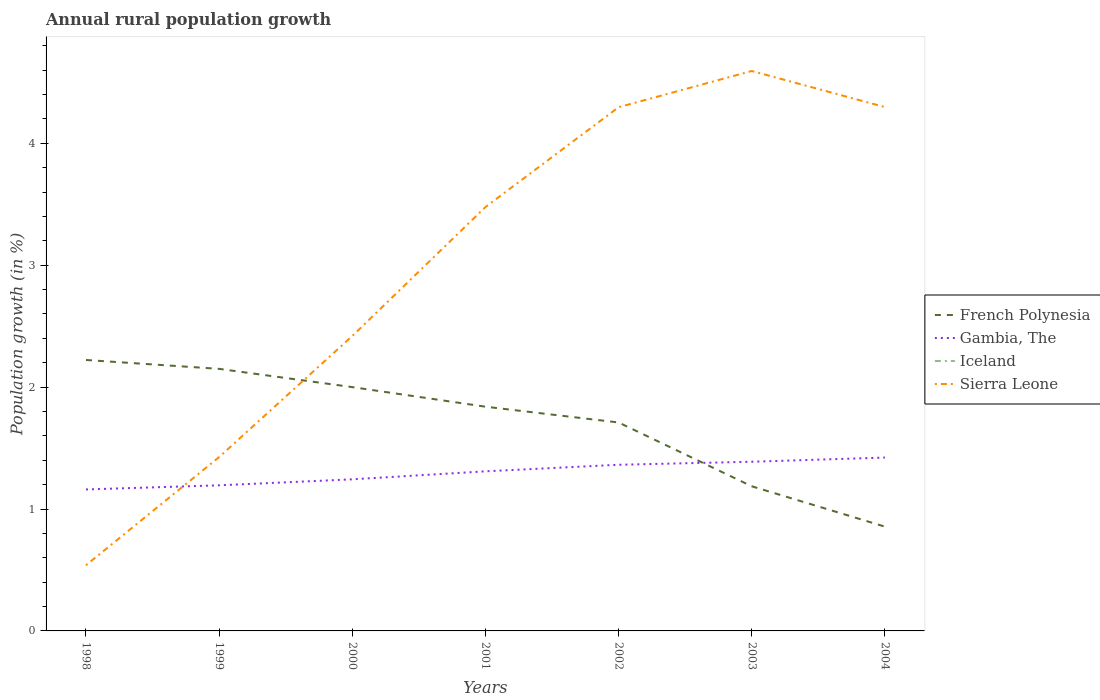What is the total percentage of rural population growth in French Polynesia in the graph?
Your answer should be compact. 1.04. What is the difference between the highest and the second highest percentage of rural population growth in Sierra Leone?
Make the answer very short. 4.05. What is the difference between the highest and the lowest percentage of rural population growth in French Polynesia?
Your answer should be very brief. 5. How many lines are there?
Offer a terse response. 3. Does the graph contain any zero values?
Make the answer very short. Yes. Does the graph contain grids?
Provide a succinct answer. No. Where does the legend appear in the graph?
Offer a very short reply. Center right. How many legend labels are there?
Offer a terse response. 4. How are the legend labels stacked?
Offer a very short reply. Vertical. What is the title of the graph?
Offer a very short reply. Annual rural population growth. Does "Ireland" appear as one of the legend labels in the graph?
Provide a succinct answer. No. What is the label or title of the Y-axis?
Your answer should be very brief. Population growth (in %). What is the Population growth (in %) in French Polynesia in 1998?
Provide a short and direct response. 2.22. What is the Population growth (in %) in Gambia, The in 1998?
Provide a short and direct response. 1.16. What is the Population growth (in %) in Iceland in 1998?
Your answer should be very brief. 0. What is the Population growth (in %) in Sierra Leone in 1998?
Ensure brevity in your answer.  0.54. What is the Population growth (in %) of French Polynesia in 1999?
Your answer should be very brief. 2.15. What is the Population growth (in %) in Gambia, The in 1999?
Make the answer very short. 1.19. What is the Population growth (in %) in Iceland in 1999?
Make the answer very short. 0. What is the Population growth (in %) in Sierra Leone in 1999?
Make the answer very short. 1.43. What is the Population growth (in %) in French Polynesia in 2000?
Offer a terse response. 2. What is the Population growth (in %) of Gambia, The in 2000?
Keep it short and to the point. 1.24. What is the Population growth (in %) of Iceland in 2000?
Offer a very short reply. 0. What is the Population growth (in %) of Sierra Leone in 2000?
Make the answer very short. 2.42. What is the Population growth (in %) of French Polynesia in 2001?
Provide a short and direct response. 1.84. What is the Population growth (in %) in Gambia, The in 2001?
Make the answer very short. 1.31. What is the Population growth (in %) in Iceland in 2001?
Offer a very short reply. 0. What is the Population growth (in %) in Sierra Leone in 2001?
Provide a succinct answer. 3.48. What is the Population growth (in %) in French Polynesia in 2002?
Your response must be concise. 1.71. What is the Population growth (in %) of Gambia, The in 2002?
Make the answer very short. 1.36. What is the Population growth (in %) of Iceland in 2002?
Your answer should be very brief. 0. What is the Population growth (in %) in Sierra Leone in 2002?
Offer a terse response. 4.3. What is the Population growth (in %) of French Polynesia in 2003?
Offer a terse response. 1.19. What is the Population growth (in %) in Gambia, The in 2003?
Offer a very short reply. 1.39. What is the Population growth (in %) in Iceland in 2003?
Make the answer very short. 0. What is the Population growth (in %) in Sierra Leone in 2003?
Your response must be concise. 4.59. What is the Population growth (in %) of French Polynesia in 2004?
Offer a terse response. 0.86. What is the Population growth (in %) of Gambia, The in 2004?
Offer a very short reply. 1.42. What is the Population growth (in %) of Sierra Leone in 2004?
Your response must be concise. 4.3. Across all years, what is the maximum Population growth (in %) of French Polynesia?
Keep it short and to the point. 2.22. Across all years, what is the maximum Population growth (in %) of Gambia, The?
Your answer should be compact. 1.42. Across all years, what is the maximum Population growth (in %) of Sierra Leone?
Offer a terse response. 4.59. Across all years, what is the minimum Population growth (in %) of French Polynesia?
Ensure brevity in your answer.  0.86. Across all years, what is the minimum Population growth (in %) of Gambia, The?
Your answer should be very brief. 1.16. Across all years, what is the minimum Population growth (in %) of Sierra Leone?
Give a very brief answer. 0.54. What is the total Population growth (in %) in French Polynesia in the graph?
Give a very brief answer. 11.96. What is the total Population growth (in %) of Gambia, The in the graph?
Your answer should be very brief. 9.08. What is the total Population growth (in %) of Sierra Leone in the graph?
Provide a short and direct response. 21.05. What is the difference between the Population growth (in %) in French Polynesia in 1998 and that in 1999?
Give a very brief answer. 0.07. What is the difference between the Population growth (in %) of Gambia, The in 1998 and that in 1999?
Your response must be concise. -0.03. What is the difference between the Population growth (in %) in Sierra Leone in 1998 and that in 1999?
Provide a succinct answer. -0.89. What is the difference between the Population growth (in %) of French Polynesia in 1998 and that in 2000?
Provide a short and direct response. 0.22. What is the difference between the Population growth (in %) in Gambia, The in 1998 and that in 2000?
Ensure brevity in your answer.  -0.08. What is the difference between the Population growth (in %) of Sierra Leone in 1998 and that in 2000?
Your answer should be compact. -1.88. What is the difference between the Population growth (in %) in French Polynesia in 1998 and that in 2001?
Keep it short and to the point. 0.38. What is the difference between the Population growth (in %) in Gambia, The in 1998 and that in 2001?
Offer a very short reply. -0.15. What is the difference between the Population growth (in %) in Sierra Leone in 1998 and that in 2001?
Your response must be concise. -2.94. What is the difference between the Population growth (in %) in French Polynesia in 1998 and that in 2002?
Keep it short and to the point. 0.51. What is the difference between the Population growth (in %) in Gambia, The in 1998 and that in 2002?
Provide a succinct answer. -0.2. What is the difference between the Population growth (in %) in Sierra Leone in 1998 and that in 2002?
Give a very brief answer. -3.76. What is the difference between the Population growth (in %) in French Polynesia in 1998 and that in 2003?
Provide a short and direct response. 1.04. What is the difference between the Population growth (in %) of Gambia, The in 1998 and that in 2003?
Provide a short and direct response. -0.23. What is the difference between the Population growth (in %) in Sierra Leone in 1998 and that in 2003?
Keep it short and to the point. -4.05. What is the difference between the Population growth (in %) in French Polynesia in 1998 and that in 2004?
Your answer should be very brief. 1.37. What is the difference between the Population growth (in %) in Gambia, The in 1998 and that in 2004?
Ensure brevity in your answer.  -0.26. What is the difference between the Population growth (in %) in Sierra Leone in 1998 and that in 2004?
Provide a short and direct response. -3.76. What is the difference between the Population growth (in %) in French Polynesia in 1999 and that in 2000?
Your response must be concise. 0.15. What is the difference between the Population growth (in %) in Gambia, The in 1999 and that in 2000?
Ensure brevity in your answer.  -0.05. What is the difference between the Population growth (in %) of Sierra Leone in 1999 and that in 2000?
Give a very brief answer. -0.99. What is the difference between the Population growth (in %) in French Polynesia in 1999 and that in 2001?
Offer a very short reply. 0.31. What is the difference between the Population growth (in %) of Gambia, The in 1999 and that in 2001?
Make the answer very short. -0.11. What is the difference between the Population growth (in %) of Sierra Leone in 1999 and that in 2001?
Your answer should be very brief. -2.05. What is the difference between the Population growth (in %) of French Polynesia in 1999 and that in 2002?
Provide a short and direct response. 0.44. What is the difference between the Population growth (in %) of Gambia, The in 1999 and that in 2002?
Your answer should be very brief. -0.17. What is the difference between the Population growth (in %) in Sierra Leone in 1999 and that in 2002?
Offer a very short reply. -2.87. What is the difference between the Population growth (in %) in French Polynesia in 1999 and that in 2003?
Keep it short and to the point. 0.96. What is the difference between the Population growth (in %) of Gambia, The in 1999 and that in 2003?
Provide a succinct answer. -0.19. What is the difference between the Population growth (in %) in Sierra Leone in 1999 and that in 2003?
Offer a very short reply. -3.17. What is the difference between the Population growth (in %) of French Polynesia in 1999 and that in 2004?
Your response must be concise. 1.29. What is the difference between the Population growth (in %) of Gambia, The in 1999 and that in 2004?
Your answer should be very brief. -0.23. What is the difference between the Population growth (in %) in Sierra Leone in 1999 and that in 2004?
Provide a short and direct response. -2.87. What is the difference between the Population growth (in %) in French Polynesia in 2000 and that in 2001?
Provide a succinct answer. 0.16. What is the difference between the Population growth (in %) in Gambia, The in 2000 and that in 2001?
Provide a succinct answer. -0.07. What is the difference between the Population growth (in %) in Sierra Leone in 2000 and that in 2001?
Your response must be concise. -1.06. What is the difference between the Population growth (in %) of French Polynesia in 2000 and that in 2002?
Your answer should be very brief. 0.29. What is the difference between the Population growth (in %) of Gambia, The in 2000 and that in 2002?
Offer a terse response. -0.12. What is the difference between the Population growth (in %) in Sierra Leone in 2000 and that in 2002?
Provide a succinct answer. -1.88. What is the difference between the Population growth (in %) of French Polynesia in 2000 and that in 2003?
Offer a terse response. 0.81. What is the difference between the Population growth (in %) of Gambia, The in 2000 and that in 2003?
Your answer should be very brief. -0.14. What is the difference between the Population growth (in %) in Sierra Leone in 2000 and that in 2003?
Make the answer very short. -2.17. What is the difference between the Population growth (in %) in French Polynesia in 2000 and that in 2004?
Your answer should be very brief. 1.14. What is the difference between the Population growth (in %) in Gambia, The in 2000 and that in 2004?
Ensure brevity in your answer.  -0.18. What is the difference between the Population growth (in %) of Sierra Leone in 2000 and that in 2004?
Ensure brevity in your answer.  -1.88. What is the difference between the Population growth (in %) of French Polynesia in 2001 and that in 2002?
Make the answer very short. 0.13. What is the difference between the Population growth (in %) of Gambia, The in 2001 and that in 2002?
Offer a terse response. -0.05. What is the difference between the Population growth (in %) in Sierra Leone in 2001 and that in 2002?
Keep it short and to the point. -0.82. What is the difference between the Population growth (in %) of French Polynesia in 2001 and that in 2003?
Provide a succinct answer. 0.65. What is the difference between the Population growth (in %) in Gambia, The in 2001 and that in 2003?
Your answer should be compact. -0.08. What is the difference between the Population growth (in %) of Sierra Leone in 2001 and that in 2003?
Your answer should be very brief. -1.12. What is the difference between the Population growth (in %) of French Polynesia in 2001 and that in 2004?
Ensure brevity in your answer.  0.98. What is the difference between the Population growth (in %) of Gambia, The in 2001 and that in 2004?
Offer a terse response. -0.11. What is the difference between the Population growth (in %) in Sierra Leone in 2001 and that in 2004?
Offer a very short reply. -0.82. What is the difference between the Population growth (in %) in French Polynesia in 2002 and that in 2003?
Your response must be concise. 0.52. What is the difference between the Population growth (in %) of Gambia, The in 2002 and that in 2003?
Make the answer very short. -0.02. What is the difference between the Population growth (in %) in Sierra Leone in 2002 and that in 2003?
Make the answer very short. -0.3. What is the difference between the Population growth (in %) in French Polynesia in 2002 and that in 2004?
Your answer should be very brief. 0.85. What is the difference between the Population growth (in %) in Gambia, The in 2002 and that in 2004?
Your response must be concise. -0.06. What is the difference between the Population growth (in %) in Sierra Leone in 2002 and that in 2004?
Your answer should be compact. -0. What is the difference between the Population growth (in %) in French Polynesia in 2003 and that in 2004?
Make the answer very short. 0.33. What is the difference between the Population growth (in %) of Gambia, The in 2003 and that in 2004?
Your answer should be very brief. -0.03. What is the difference between the Population growth (in %) of Sierra Leone in 2003 and that in 2004?
Offer a terse response. 0.3. What is the difference between the Population growth (in %) in French Polynesia in 1998 and the Population growth (in %) in Gambia, The in 1999?
Your answer should be compact. 1.03. What is the difference between the Population growth (in %) in French Polynesia in 1998 and the Population growth (in %) in Sierra Leone in 1999?
Make the answer very short. 0.8. What is the difference between the Population growth (in %) of Gambia, The in 1998 and the Population growth (in %) of Sierra Leone in 1999?
Keep it short and to the point. -0.27. What is the difference between the Population growth (in %) in French Polynesia in 1998 and the Population growth (in %) in Gambia, The in 2000?
Provide a short and direct response. 0.98. What is the difference between the Population growth (in %) of French Polynesia in 1998 and the Population growth (in %) of Sierra Leone in 2000?
Provide a succinct answer. -0.2. What is the difference between the Population growth (in %) in Gambia, The in 1998 and the Population growth (in %) in Sierra Leone in 2000?
Offer a very short reply. -1.26. What is the difference between the Population growth (in %) in French Polynesia in 1998 and the Population growth (in %) in Gambia, The in 2001?
Offer a terse response. 0.91. What is the difference between the Population growth (in %) in French Polynesia in 1998 and the Population growth (in %) in Sierra Leone in 2001?
Offer a terse response. -1.25. What is the difference between the Population growth (in %) of Gambia, The in 1998 and the Population growth (in %) of Sierra Leone in 2001?
Your answer should be very brief. -2.32. What is the difference between the Population growth (in %) in French Polynesia in 1998 and the Population growth (in %) in Gambia, The in 2002?
Offer a very short reply. 0.86. What is the difference between the Population growth (in %) in French Polynesia in 1998 and the Population growth (in %) in Sierra Leone in 2002?
Offer a very short reply. -2.07. What is the difference between the Population growth (in %) in Gambia, The in 1998 and the Population growth (in %) in Sierra Leone in 2002?
Make the answer very short. -3.14. What is the difference between the Population growth (in %) in French Polynesia in 1998 and the Population growth (in %) in Gambia, The in 2003?
Provide a succinct answer. 0.83. What is the difference between the Population growth (in %) of French Polynesia in 1998 and the Population growth (in %) of Sierra Leone in 2003?
Give a very brief answer. -2.37. What is the difference between the Population growth (in %) of Gambia, The in 1998 and the Population growth (in %) of Sierra Leone in 2003?
Your response must be concise. -3.43. What is the difference between the Population growth (in %) of French Polynesia in 1998 and the Population growth (in %) of Gambia, The in 2004?
Your answer should be very brief. 0.8. What is the difference between the Population growth (in %) in French Polynesia in 1998 and the Population growth (in %) in Sierra Leone in 2004?
Ensure brevity in your answer.  -2.07. What is the difference between the Population growth (in %) in Gambia, The in 1998 and the Population growth (in %) in Sierra Leone in 2004?
Your answer should be compact. -3.14. What is the difference between the Population growth (in %) of French Polynesia in 1999 and the Population growth (in %) of Gambia, The in 2000?
Keep it short and to the point. 0.91. What is the difference between the Population growth (in %) of French Polynesia in 1999 and the Population growth (in %) of Sierra Leone in 2000?
Offer a terse response. -0.27. What is the difference between the Population growth (in %) in Gambia, The in 1999 and the Population growth (in %) in Sierra Leone in 2000?
Offer a very short reply. -1.22. What is the difference between the Population growth (in %) in French Polynesia in 1999 and the Population growth (in %) in Gambia, The in 2001?
Provide a succinct answer. 0.84. What is the difference between the Population growth (in %) of French Polynesia in 1999 and the Population growth (in %) of Sierra Leone in 2001?
Make the answer very short. -1.33. What is the difference between the Population growth (in %) of Gambia, The in 1999 and the Population growth (in %) of Sierra Leone in 2001?
Your response must be concise. -2.28. What is the difference between the Population growth (in %) of French Polynesia in 1999 and the Population growth (in %) of Gambia, The in 2002?
Provide a succinct answer. 0.79. What is the difference between the Population growth (in %) of French Polynesia in 1999 and the Population growth (in %) of Sierra Leone in 2002?
Provide a succinct answer. -2.15. What is the difference between the Population growth (in %) in Gambia, The in 1999 and the Population growth (in %) in Sierra Leone in 2002?
Make the answer very short. -3.1. What is the difference between the Population growth (in %) in French Polynesia in 1999 and the Population growth (in %) in Gambia, The in 2003?
Your response must be concise. 0.76. What is the difference between the Population growth (in %) in French Polynesia in 1999 and the Population growth (in %) in Sierra Leone in 2003?
Provide a short and direct response. -2.44. What is the difference between the Population growth (in %) in Gambia, The in 1999 and the Population growth (in %) in Sierra Leone in 2003?
Give a very brief answer. -3.4. What is the difference between the Population growth (in %) of French Polynesia in 1999 and the Population growth (in %) of Gambia, The in 2004?
Provide a succinct answer. 0.73. What is the difference between the Population growth (in %) of French Polynesia in 1999 and the Population growth (in %) of Sierra Leone in 2004?
Give a very brief answer. -2.15. What is the difference between the Population growth (in %) of Gambia, The in 1999 and the Population growth (in %) of Sierra Leone in 2004?
Offer a very short reply. -3.1. What is the difference between the Population growth (in %) of French Polynesia in 2000 and the Population growth (in %) of Gambia, The in 2001?
Keep it short and to the point. 0.69. What is the difference between the Population growth (in %) of French Polynesia in 2000 and the Population growth (in %) of Sierra Leone in 2001?
Your response must be concise. -1.48. What is the difference between the Population growth (in %) of Gambia, The in 2000 and the Population growth (in %) of Sierra Leone in 2001?
Provide a succinct answer. -2.23. What is the difference between the Population growth (in %) of French Polynesia in 2000 and the Population growth (in %) of Gambia, The in 2002?
Keep it short and to the point. 0.64. What is the difference between the Population growth (in %) of French Polynesia in 2000 and the Population growth (in %) of Sierra Leone in 2002?
Your response must be concise. -2.3. What is the difference between the Population growth (in %) of Gambia, The in 2000 and the Population growth (in %) of Sierra Leone in 2002?
Provide a succinct answer. -3.05. What is the difference between the Population growth (in %) in French Polynesia in 2000 and the Population growth (in %) in Gambia, The in 2003?
Give a very brief answer. 0.61. What is the difference between the Population growth (in %) in French Polynesia in 2000 and the Population growth (in %) in Sierra Leone in 2003?
Ensure brevity in your answer.  -2.59. What is the difference between the Population growth (in %) in Gambia, The in 2000 and the Population growth (in %) in Sierra Leone in 2003?
Your answer should be very brief. -3.35. What is the difference between the Population growth (in %) in French Polynesia in 2000 and the Population growth (in %) in Gambia, The in 2004?
Your answer should be very brief. 0.58. What is the difference between the Population growth (in %) of French Polynesia in 2000 and the Population growth (in %) of Sierra Leone in 2004?
Provide a succinct answer. -2.3. What is the difference between the Population growth (in %) in Gambia, The in 2000 and the Population growth (in %) in Sierra Leone in 2004?
Ensure brevity in your answer.  -3.05. What is the difference between the Population growth (in %) of French Polynesia in 2001 and the Population growth (in %) of Gambia, The in 2002?
Your answer should be very brief. 0.48. What is the difference between the Population growth (in %) in French Polynesia in 2001 and the Population growth (in %) in Sierra Leone in 2002?
Keep it short and to the point. -2.46. What is the difference between the Population growth (in %) in Gambia, The in 2001 and the Population growth (in %) in Sierra Leone in 2002?
Your response must be concise. -2.99. What is the difference between the Population growth (in %) in French Polynesia in 2001 and the Population growth (in %) in Gambia, The in 2003?
Keep it short and to the point. 0.45. What is the difference between the Population growth (in %) in French Polynesia in 2001 and the Population growth (in %) in Sierra Leone in 2003?
Your answer should be very brief. -2.75. What is the difference between the Population growth (in %) of Gambia, The in 2001 and the Population growth (in %) of Sierra Leone in 2003?
Make the answer very short. -3.28. What is the difference between the Population growth (in %) of French Polynesia in 2001 and the Population growth (in %) of Gambia, The in 2004?
Offer a terse response. 0.42. What is the difference between the Population growth (in %) in French Polynesia in 2001 and the Population growth (in %) in Sierra Leone in 2004?
Your answer should be very brief. -2.46. What is the difference between the Population growth (in %) in Gambia, The in 2001 and the Population growth (in %) in Sierra Leone in 2004?
Make the answer very short. -2.99. What is the difference between the Population growth (in %) of French Polynesia in 2002 and the Population growth (in %) of Gambia, The in 2003?
Keep it short and to the point. 0.32. What is the difference between the Population growth (in %) of French Polynesia in 2002 and the Population growth (in %) of Sierra Leone in 2003?
Give a very brief answer. -2.88. What is the difference between the Population growth (in %) in Gambia, The in 2002 and the Population growth (in %) in Sierra Leone in 2003?
Your answer should be very brief. -3.23. What is the difference between the Population growth (in %) of French Polynesia in 2002 and the Population growth (in %) of Gambia, The in 2004?
Give a very brief answer. 0.29. What is the difference between the Population growth (in %) of French Polynesia in 2002 and the Population growth (in %) of Sierra Leone in 2004?
Give a very brief answer. -2.59. What is the difference between the Population growth (in %) of Gambia, The in 2002 and the Population growth (in %) of Sierra Leone in 2004?
Give a very brief answer. -2.93. What is the difference between the Population growth (in %) in French Polynesia in 2003 and the Population growth (in %) in Gambia, The in 2004?
Ensure brevity in your answer.  -0.24. What is the difference between the Population growth (in %) of French Polynesia in 2003 and the Population growth (in %) of Sierra Leone in 2004?
Provide a short and direct response. -3.11. What is the difference between the Population growth (in %) in Gambia, The in 2003 and the Population growth (in %) in Sierra Leone in 2004?
Offer a terse response. -2.91. What is the average Population growth (in %) of French Polynesia per year?
Offer a very short reply. 1.71. What is the average Population growth (in %) of Gambia, The per year?
Your answer should be very brief. 1.3. What is the average Population growth (in %) of Iceland per year?
Ensure brevity in your answer.  0. What is the average Population growth (in %) in Sierra Leone per year?
Make the answer very short. 3.01. In the year 1998, what is the difference between the Population growth (in %) in French Polynesia and Population growth (in %) in Gambia, The?
Offer a terse response. 1.06. In the year 1998, what is the difference between the Population growth (in %) in French Polynesia and Population growth (in %) in Sierra Leone?
Your answer should be very brief. 1.68. In the year 1998, what is the difference between the Population growth (in %) of Gambia, The and Population growth (in %) of Sierra Leone?
Your response must be concise. 0.62. In the year 1999, what is the difference between the Population growth (in %) in French Polynesia and Population growth (in %) in Gambia, The?
Your answer should be compact. 0.96. In the year 1999, what is the difference between the Population growth (in %) of French Polynesia and Population growth (in %) of Sierra Leone?
Ensure brevity in your answer.  0.72. In the year 1999, what is the difference between the Population growth (in %) in Gambia, The and Population growth (in %) in Sierra Leone?
Your response must be concise. -0.23. In the year 2000, what is the difference between the Population growth (in %) of French Polynesia and Population growth (in %) of Gambia, The?
Offer a terse response. 0.76. In the year 2000, what is the difference between the Population growth (in %) of French Polynesia and Population growth (in %) of Sierra Leone?
Offer a very short reply. -0.42. In the year 2000, what is the difference between the Population growth (in %) in Gambia, The and Population growth (in %) in Sierra Leone?
Offer a very short reply. -1.18. In the year 2001, what is the difference between the Population growth (in %) in French Polynesia and Population growth (in %) in Gambia, The?
Make the answer very short. 0.53. In the year 2001, what is the difference between the Population growth (in %) in French Polynesia and Population growth (in %) in Sierra Leone?
Your response must be concise. -1.64. In the year 2001, what is the difference between the Population growth (in %) of Gambia, The and Population growth (in %) of Sierra Leone?
Ensure brevity in your answer.  -2.17. In the year 2002, what is the difference between the Population growth (in %) of French Polynesia and Population growth (in %) of Gambia, The?
Provide a succinct answer. 0.35. In the year 2002, what is the difference between the Population growth (in %) of French Polynesia and Population growth (in %) of Sierra Leone?
Offer a terse response. -2.59. In the year 2002, what is the difference between the Population growth (in %) of Gambia, The and Population growth (in %) of Sierra Leone?
Your answer should be compact. -2.93. In the year 2003, what is the difference between the Population growth (in %) of French Polynesia and Population growth (in %) of Gambia, The?
Keep it short and to the point. -0.2. In the year 2003, what is the difference between the Population growth (in %) of French Polynesia and Population growth (in %) of Sierra Leone?
Your answer should be very brief. -3.41. In the year 2003, what is the difference between the Population growth (in %) in Gambia, The and Population growth (in %) in Sierra Leone?
Keep it short and to the point. -3.21. In the year 2004, what is the difference between the Population growth (in %) in French Polynesia and Population growth (in %) in Gambia, The?
Your answer should be very brief. -0.57. In the year 2004, what is the difference between the Population growth (in %) of French Polynesia and Population growth (in %) of Sierra Leone?
Provide a succinct answer. -3.44. In the year 2004, what is the difference between the Population growth (in %) of Gambia, The and Population growth (in %) of Sierra Leone?
Ensure brevity in your answer.  -2.88. What is the ratio of the Population growth (in %) in French Polynesia in 1998 to that in 1999?
Keep it short and to the point. 1.03. What is the ratio of the Population growth (in %) of Gambia, The in 1998 to that in 1999?
Your answer should be very brief. 0.97. What is the ratio of the Population growth (in %) in Sierra Leone in 1998 to that in 1999?
Make the answer very short. 0.38. What is the ratio of the Population growth (in %) of French Polynesia in 1998 to that in 2000?
Give a very brief answer. 1.11. What is the ratio of the Population growth (in %) in Gambia, The in 1998 to that in 2000?
Offer a very short reply. 0.93. What is the ratio of the Population growth (in %) of Sierra Leone in 1998 to that in 2000?
Ensure brevity in your answer.  0.22. What is the ratio of the Population growth (in %) of French Polynesia in 1998 to that in 2001?
Keep it short and to the point. 1.21. What is the ratio of the Population growth (in %) of Gambia, The in 1998 to that in 2001?
Your response must be concise. 0.89. What is the ratio of the Population growth (in %) of Sierra Leone in 1998 to that in 2001?
Give a very brief answer. 0.15. What is the ratio of the Population growth (in %) of French Polynesia in 1998 to that in 2002?
Offer a very short reply. 1.3. What is the ratio of the Population growth (in %) in Gambia, The in 1998 to that in 2002?
Give a very brief answer. 0.85. What is the ratio of the Population growth (in %) in Sierra Leone in 1998 to that in 2002?
Make the answer very short. 0.13. What is the ratio of the Population growth (in %) in French Polynesia in 1998 to that in 2003?
Keep it short and to the point. 1.87. What is the ratio of the Population growth (in %) of Gambia, The in 1998 to that in 2003?
Ensure brevity in your answer.  0.84. What is the ratio of the Population growth (in %) of Sierra Leone in 1998 to that in 2003?
Your response must be concise. 0.12. What is the ratio of the Population growth (in %) of French Polynesia in 1998 to that in 2004?
Offer a very short reply. 2.6. What is the ratio of the Population growth (in %) of Gambia, The in 1998 to that in 2004?
Provide a short and direct response. 0.82. What is the ratio of the Population growth (in %) in Sierra Leone in 1998 to that in 2004?
Offer a terse response. 0.13. What is the ratio of the Population growth (in %) of French Polynesia in 1999 to that in 2000?
Make the answer very short. 1.07. What is the ratio of the Population growth (in %) of Gambia, The in 1999 to that in 2000?
Offer a terse response. 0.96. What is the ratio of the Population growth (in %) of Sierra Leone in 1999 to that in 2000?
Offer a terse response. 0.59. What is the ratio of the Population growth (in %) of French Polynesia in 1999 to that in 2001?
Your answer should be compact. 1.17. What is the ratio of the Population growth (in %) in Gambia, The in 1999 to that in 2001?
Offer a very short reply. 0.91. What is the ratio of the Population growth (in %) in Sierra Leone in 1999 to that in 2001?
Provide a succinct answer. 0.41. What is the ratio of the Population growth (in %) in French Polynesia in 1999 to that in 2002?
Offer a very short reply. 1.26. What is the ratio of the Population growth (in %) in Gambia, The in 1999 to that in 2002?
Offer a terse response. 0.88. What is the ratio of the Population growth (in %) of Sierra Leone in 1999 to that in 2002?
Ensure brevity in your answer.  0.33. What is the ratio of the Population growth (in %) in French Polynesia in 1999 to that in 2003?
Offer a terse response. 1.81. What is the ratio of the Population growth (in %) of Gambia, The in 1999 to that in 2003?
Offer a very short reply. 0.86. What is the ratio of the Population growth (in %) in Sierra Leone in 1999 to that in 2003?
Give a very brief answer. 0.31. What is the ratio of the Population growth (in %) of French Polynesia in 1999 to that in 2004?
Offer a terse response. 2.51. What is the ratio of the Population growth (in %) in Gambia, The in 1999 to that in 2004?
Your response must be concise. 0.84. What is the ratio of the Population growth (in %) in Sierra Leone in 1999 to that in 2004?
Offer a very short reply. 0.33. What is the ratio of the Population growth (in %) of French Polynesia in 2000 to that in 2001?
Your response must be concise. 1.09. What is the ratio of the Population growth (in %) of Gambia, The in 2000 to that in 2001?
Provide a short and direct response. 0.95. What is the ratio of the Population growth (in %) of Sierra Leone in 2000 to that in 2001?
Keep it short and to the point. 0.7. What is the ratio of the Population growth (in %) of French Polynesia in 2000 to that in 2002?
Your answer should be very brief. 1.17. What is the ratio of the Population growth (in %) of Gambia, The in 2000 to that in 2002?
Provide a succinct answer. 0.91. What is the ratio of the Population growth (in %) of Sierra Leone in 2000 to that in 2002?
Provide a short and direct response. 0.56. What is the ratio of the Population growth (in %) in French Polynesia in 2000 to that in 2003?
Your answer should be very brief. 1.69. What is the ratio of the Population growth (in %) of Gambia, The in 2000 to that in 2003?
Make the answer very short. 0.9. What is the ratio of the Population growth (in %) in Sierra Leone in 2000 to that in 2003?
Offer a very short reply. 0.53. What is the ratio of the Population growth (in %) of French Polynesia in 2000 to that in 2004?
Provide a succinct answer. 2.34. What is the ratio of the Population growth (in %) in Gambia, The in 2000 to that in 2004?
Make the answer very short. 0.87. What is the ratio of the Population growth (in %) of Sierra Leone in 2000 to that in 2004?
Your answer should be compact. 0.56. What is the ratio of the Population growth (in %) of French Polynesia in 2001 to that in 2002?
Your response must be concise. 1.08. What is the ratio of the Population growth (in %) of Gambia, The in 2001 to that in 2002?
Provide a succinct answer. 0.96. What is the ratio of the Population growth (in %) in Sierra Leone in 2001 to that in 2002?
Keep it short and to the point. 0.81. What is the ratio of the Population growth (in %) in French Polynesia in 2001 to that in 2003?
Offer a terse response. 1.55. What is the ratio of the Population growth (in %) of Gambia, The in 2001 to that in 2003?
Offer a very short reply. 0.94. What is the ratio of the Population growth (in %) of Sierra Leone in 2001 to that in 2003?
Keep it short and to the point. 0.76. What is the ratio of the Population growth (in %) of French Polynesia in 2001 to that in 2004?
Offer a terse response. 2.15. What is the ratio of the Population growth (in %) of Gambia, The in 2001 to that in 2004?
Offer a terse response. 0.92. What is the ratio of the Population growth (in %) of Sierra Leone in 2001 to that in 2004?
Provide a short and direct response. 0.81. What is the ratio of the Population growth (in %) of French Polynesia in 2002 to that in 2003?
Your answer should be compact. 1.44. What is the ratio of the Population growth (in %) of Gambia, The in 2002 to that in 2003?
Your answer should be very brief. 0.98. What is the ratio of the Population growth (in %) in Sierra Leone in 2002 to that in 2003?
Make the answer very short. 0.94. What is the ratio of the Population growth (in %) in French Polynesia in 2002 to that in 2004?
Offer a very short reply. 2. What is the ratio of the Population growth (in %) of Gambia, The in 2002 to that in 2004?
Offer a very short reply. 0.96. What is the ratio of the Population growth (in %) of French Polynesia in 2003 to that in 2004?
Give a very brief answer. 1.39. What is the ratio of the Population growth (in %) of Gambia, The in 2003 to that in 2004?
Give a very brief answer. 0.98. What is the ratio of the Population growth (in %) in Sierra Leone in 2003 to that in 2004?
Provide a short and direct response. 1.07. What is the difference between the highest and the second highest Population growth (in %) of French Polynesia?
Your response must be concise. 0.07. What is the difference between the highest and the second highest Population growth (in %) of Gambia, The?
Make the answer very short. 0.03. What is the difference between the highest and the second highest Population growth (in %) of Sierra Leone?
Ensure brevity in your answer.  0.3. What is the difference between the highest and the lowest Population growth (in %) of French Polynesia?
Make the answer very short. 1.37. What is the difference between the highest and the lowest Population growth (in %) in Gambia, The?
Give a very brief answer. 0.26. What is the difference between the highest and the lowest Population growth (in %) of Sierra Leone?
Provide a short and direct response. 4.05. 